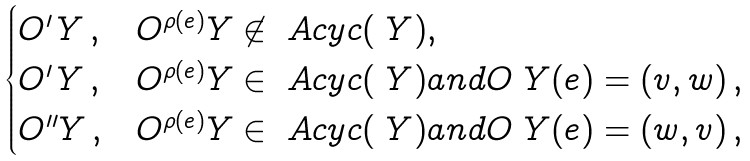<formula> <loc_0><loc_0><loc_500><loc_500>\begin{cases} O ^ { \prime } _ { \ } Y \, , & O ^ { \rho ( e ) } _ { \ } Y \not \in \ A c y c ( \ Y ) , \\ O ^ { \prime } _ { \ } Y \, , & O ^ { \rho ( e ) } _ { \ } Y \in \ A c y c ( \ Y ) a n d O _ { \ } Y ( e ) = ( v , w ) \, , \\ O ^ { \prime \prime } _ { \ } Y \, , & O ^ { \rho ( e ) } _ { \ } Y \in \ A c y c ( \ Y ) a n d O _ { \ } Y ( e ) = ( w , v ) \, , \\ \end{cases}</formula> 